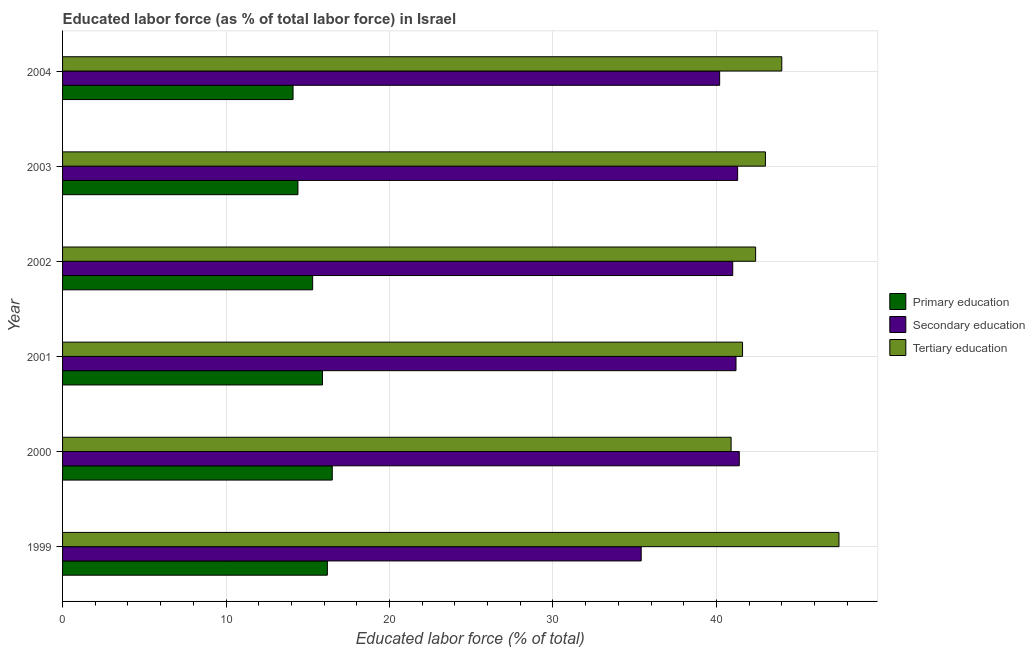How many different coloured bars are there?
Offer a very short reply. 3. How many groups of bars are there?
Make the answer very short. 6. Are the number of bars on each tick of the Y-axis equal?
Your answer should be very brief. Yes. What is the label of the 6th group of bars from the top?
Keep it short and to the point. 1999. What is the percentage of labor force who received secondary education in 2004?
Ensure brevity in your answer.  40.2. Across all years, what is the minimum percentage of labor force who received primary education?
Give a very brief answer. 14.1. In which year was the percentage of labor force who received primary education maximum?
Keep it short and to the point. 2000. In which year was the percentage of labor force who received primary education minimum?
Ensure brevity in your answer.  2004. What is the total percentage of labor force who received primary education in the graph?
Your response must be concise. 92.4. What is the difference between the percentage of labor force who received secondary education in 2001 and the percentage of labor force who received primary education in 2000?
Offer a terse response. 24.7. What is the average percentage of labor force who received secondary education per year?
Your answer should be very brief. 40.08. In the year 2000, what is the difference between the percentage of labor force who received tertiary education and percentage of labor force who received primary education?
Offer a terse response. 24.4. What is the ratio of the percentage of labor force who received secondary education in 1999 to that in 2002?
Give a very brief answer. 0.86. Is the sum of the percentage of labor force who received secondary education in 2000 and 2004 greater than the maximum percentage of labor force who received primary education across all years?
Your answer should be very brief. Yes. What does the 1st bar from the top in 2000 represents?
Your response must be concise. Tertiary education. What does the 3rd bar from the bottom in 2001 represents?
Make the answer very short. Tertiary education. Is it the case that in every year, the sum of the percentage of labor force who received primary education and percentage of labor force who received secondary education is greater than the percentage of labor force who received tertiary education?
Your answer should be very brief. Yes. What is the difference between two consecutive major ticks on the X-axis?
Ensure brevity in your answer.  10. Does the graph contain any zero values?
Your response must be concise. No. How many legend labels are there?
Your answer should be compact. 3. What is the title of the graph?
Provide a short and direct response. Educated labor force (as % of total labor force) in Israel. Does "Consumption Tax" appear as one of the legend labels in the graph?
Ensure brevity in your answer.  No. What is the label or title of the X-axis?
Offer a very short reply. Educated labor force (% of total). What is the label or title of the Y-axis?
Keep it short and to the point. Year. What is the Educated labor force (% of total) of Primary education in 1999?
Offer a terse response. 16.2. What is the Educated labor force (% of total) of Secondary education in 1999?
Your answer should be very brief. 35.4. What is the Educated labor force (% of total) in Tertiary education in 1999?
Give a very brief answer. 47.5. What is the Educated labor force (% of total) of Primary education in 2000?
Make the answer very short. 16.5. What is the Educated labor force (% of total) of Secondary education in 2000?
Offer a very short reply. 41.4. What is the Educated labor force (% of total) in Tertiary education in 2000?
Provide a succinct answer. 40.9. What is the Educated labor force (% of total) of Primary education in 2001?
Your answer should be very brief. 15.9. What is the Educated labor force (% of total) in Secondary education in 2001?
Provide a short and direct response. 41.2. What is the Educated labor force (% of total) of Tertiary education in 2001?
Your answer should be compact. 41.6. What is the Educated labor force (% of total) in Primary education in 2002?
Provide a short and direct response. 15.3. What is the Educated labor force (% of total) of Secondary education in 2002?
Offer a terse response. 41. What is the Educated labor force (% of total) in Tertiary education in 2002?
Your answer should be very brief. 42.4. What is the Educated labor force (% of total) in Primary education in 2003?
Ensure brevity in your answer.  14.4. What is the Educated labor force (% of total) in Secondary education in 2003?
Your answer should be compact. 41.3. What is the Educated labor force (% of total) of Primary education in 2004?
Keep it short and to the point. 14.1. What is the Educated labor force (% of total) of Secondary education in 2004?
Provide a short and direct response. 40.2. Across all years, what is the maximum Educated labor force (% of total) of Secondary education?
Your response must be concise. 41.4. Across all years, what is the maximum Educated labor force (% of total) in Tertiary education?
Make the answer very short. 47.5. Across all years, what is the minimum Educated labor force (% of total) of Primary education?
Provide a succinct answer. 14.1. Across all years, what is the minimum Educated labor force (% of total) in Secondary education?
Your answer should be very brief. 35.4. Across all years, what is the minimum Educated labor force (% of total) of Tertiary education?
Offer a terse response. 40.9. What is the total Educated labor force (% of total) of Primary education in the graph?
Provide a short and direct response. 92.4. What is the total Educated labor force (% of total) in Secondary education in the graph?
Provide a short and direct response. 240.5. What is the total Educated labor force (% of total) in Tertiary education in the graph?
Provide a short and direct response. 259.4. What is the difference between the Educated labor force (% of total) of Primary education in 1999 and that in 2001?
Make the answer very short. 0.3. What is the difference between the Educated labor force (% of total) of Secondary education in 1999 and that in 2001?
Your response must be concise. -5.8. What is the difference between the Educated labor force (% of total) in Tertiary education in 1999 and that in 2001?
Provide a short and direct response. 5.9. What is the difference between the Educated labor force (% of total) in Primary education in 1999 and that in 2002?
Make the answer very short. 0.9. What is the difference between the Educated labor force (% of total) of Tertiary education in 1999 and that in 2003?
Offer a terse response. 4.5. What is the difference between the Educated labor force (% of total) in Tertiary education in 2000 and that in 2001?
Offer a very short reply. -0.7. What is the difference between the Educated labor force (% of total) in Primary education in 2000 and that in 2002?
Keep it short and to the point. 1.2. What is the difference between the Educated labor force (% of total) of Secondary education in 2000 and that in 2002?
Give a very brief answer. 0.4. What is the difference between the Educated labor force (% of total) in Secondary education in 2000 and that in 2003?
Your answer should be very brief. 0.1. What is the difference between the Educated labor force (% of total) of Tertiary education in 2000 and that in 2003?
Provide a succinct answer. -2.1. What is the difference between the Educated labor force (% of total) in Secondary education in 2000 and that in 2004?
Make the answer very short. 1.2. What is the difference between the Educated labor force (% of total) in Primary education in 2001 and that in 2003?
Provide a short and direct response. 1.5. What is the difference between the Educated labor force (% of total) of Tertiary education in 2002 and that in 2003?
Provide a succinct answer. -0.6. What is the difference between the Educated labor force (% of total) of Primary education in 2002 and that in 2004?
Provide a short and direct response. 1.2. What is the difference between the Educated labor force (% of total) in Tertiary education in 2002 and that in 2004?
Ensure brevity in your answer.  -1.6. What is the difference between the Educated labor force (% of total) in Primary education in 2003 and that in 2004?
Provide a short and direct response. 0.3. What is the difference between the Educated labor force (% of total) in Secondary education in 2003 and that in 2004?
Make the answer very short. 1.1. What is the difference between the Educated labor force (% of total) of Primary education in 1999 and the Educated labor force (% of total) of Secondary education in 2000?
Your answer should be very brief. -25.2. What is the difference between the Educated labor force (% of total) of Primary education in 1999 and the Educated labor force (% of total) of Tertiary education in 2000?
Offer a terse response. -24.7. What is the difference between the Educated labor force (% of total) in Secondary education in 1999 and the Educated labor force (% of total) in Tertiary education in 2000?
Keep it short and to the point. -5.5. What is the difference between the Educated labor force (% of total) of Primary education in 1999 and the Educated labor force (% of total) of Secondary education in 2001?
Ensure brevity in your answer.  -25. What is the difference between the Educated labor force (% of total) in Primary education in 1999 and the Educated labor force (% of total) in Tertiary education in 2001?
Make the answer very short. -25.4. What is the difference between the Educated labor force (% of total) of Secondary education in 1999 and the Educated labor force (% of total) of Tertiary education in 2001?
Offer a very short reply. -6.2. What is the difference between the Educated labor force (% of total) of Primary education in 1999 and the Educated labor force (% of total) of Secondary education in 2002?
Offer a terse response. -24.8. What is the difference between the Educated labor force (% of total) of Primary education in 1999 and the Educated labor force (% of total) of Tertiary education in 2002?
Offer a terse response. -26.2. What is the difference between the Educated labor force (% of total) of Secondary education in 1999 and the Educated labor force (% of total) of Tertiary education in 2002?
Your response must be concise. -7. What is the difference between the Educated labor force (% of total) in Primary education in 1999 and the Educated labor force (% of total) in Secondary education in 2003?
Give a very brief answer. -25.1. What is the difference between the Educated labor force (% of total) in Primary education in 1999 and the Educated labor force (% of total) in Tertiary education in 2003?
Provide a short and direct response. -26.8. What is the difference between the Educated labor force (% of total) of Secondary education in 1999 and the Educated labor force (% of total) of Tertiary education in 2003?
Keep it short and to the point. -7.6. What is the difference between the Educated labor force (% of total) in Primary education in 1999 and the Educated labor force (% of total) in Tertiary education in 2004?
Offer a very short reply. -27.8. What is the difference between the Educated labor force (% of total) in Primary education in 2000 and the Educated labor force (% of total) in Secondary education in 2001?
Provide a short and direct response. -24.7. What is the difference between the Educated labor force (% of total) in Primary education in 2000 and the Educated labor force (% of total) in Tertiary education in 2001?
Your answer should be very brief. -25.1. What is the difference between the Educated labor force (% of total) in Secondary education in 2000 and the Educated labor force (% of total) in Tertiary education in 2001?
Your response must be concise. -0.2. What is the difference between the Educated labor force (% of total) in Primary education in 2000 and the Educated labor force (% of total) in Secondary education in 2002?
Provide a succinct answer. -24.5. What is the difference between the Educated labor force (% of total) of Primary education in 2000 and the Educated labor force (% of total) of Tertiary education in 2002?
Ensure brevity in your answer.  -25.9. What is the difference between the Educated labor force (% of total) in Primary education in 2000 and the Educated labor force (% of total) in Secondary education in 2003?
Offer a very short reply. -24.8. What is the difference between the Educated labor force (% of total) of Primary education in 2000 and the Educated labor force (% of total) of Tertiary education in 2003?
Your response must be concise. -26.5. What is the difference between the Educated labor force (% of total) of Secondary education in 2000 and the Educated labor force (% of total) of Tertiary education in 2003?
Your response must be concise. -1.6. What is the difference between the Educated labor force (% of total) in Primary education in 2000 and the Educated labor force (% of total) in Secondary education in 2004?
Make the answer very short. -23.7. What is the difference between the Educated labor force (% of total) in Primary education in 2000 and the Educated labor force (% of total) in Tertiary education in 2004?
Provide a succinct answer. -27.5. What is the difference between the Educated labor force (% of total) in Primary education in 2001 and the Educated labor force (% of total) in Secondary education in 2002?
Offer a terse response. -25.1. What is the difference between the Educated labor force (% of total) of Primary education in 2001 and the Educated labor force (% of total) of Tertiary education in 2002?
Your response must be concise. -26.5. What is the difference between the Educated labor force (% of total) of Primary education in 2001 and the Educated labor force (% of total) of Secondary education in 2003?
Your answer should be very brief. -25.4. What is the difference between the Educated labor force (% of total) in Primary education in 2001 and the Educated labor force (% of total) in Tertiary education in 2003?
Ensure brevity in your answer.  -27.1. What is the difference between the Educated labor force (% of total) of Primary education in 2001 and the Educated labor force (% of total) of Secondary education in 2004?
Offer a terse response. -24.3. What is the difference between the Educated labor force (% of total) of Primary education in 2001 and the Educated labor force (% of total) of Tertiary education in 2004?
Offer a terse response. -28.1. What is the difference between the Educated labor force (% of total) of Primary education in 2002 and the Educated labor force (% of total) of Tertiary education in 2003?
Offer a very short reply. -27.7. What is the difference between the Educated labor force (% of total) of Primary education in 2002 and the Educated labor force (% of total) of Secondary education in 2004?
Provide a succinct answer. -24.9. What is the difference between the Educated labor force (% of total) in Primary education in 2002 and the Educated labor force (% of total) in Tertiary education in 2004?
Your response must be concise. -28.7. What is the difference between the Educated labor force (% of total) in Primary education in 2003 and the Educated labor force (% of total) in Secondary education in 2004?
Your response must be concise. -25.8. What is the difference between the Educated labor force (% of total) of Primary education in 2003 and the Educated labor force (% of total) of Tertiary education in 2004?
Provide a short and direct response. -29.6. What is the difference between the Educated labor force (% of total) in Secondary education in 2003 and the Educated labor force (% of total) in Tertiary education in 2004?
Ensure brevity in your answer.  -2.7. What is the average Educated labor force (% of total) in Primary education per year?
Your response must be concise. 15.4. What is the average Educated labor force (% of total) of Secondary education per year?
Your response must be concise. 40.08. What is the average Educated labor force (% of total) in Tertiary education per year?
Ensure brevity in your answer.  43.23. In the year 1999, what is the difference between the Educated labor force (% of total) of Primary education and Educated labor force (% of total) of Secondary education?
Offer a very short reply. -19.2. In the year 1999, what is the difference between the Educated labor force (% of total) of Primary education and Educated labor force (% of total) of Tertiary education?
Provide a short and direct response. -31.3. In the year 2000, what is the difference between the Educated labor force (% of total) of Primary education and Educated labor force (% of total) of Secondary education?
Your answer should be very brief. -24.9. In the year 2000, what is the difference between the Educated labor force (% of total) of Primary education and Educated labor force (% of total) of Tertiary education?
Your answer should be compact. -24.4. In the year 2001, what is the difference between the Educated labor force (% of total) of Primary education and Educated labor force (% of total) of Secondary education?
Your answer should be very brief. -25.3. In the year 2001, what is the difference between the Educated labor force (% of total) of Primary education and Educated labor force (% of total) of Tertiary education?
Provide a succinct answer. -25.7. In the year 2002, what is the difference between the Educated labor force (% of total) of Primary education and Educated labor force (% of total) of Secondary education?
Ensure brevity in your answer.  -25.7. In the year 2002, what is the difference between the Educated labor force (% of total) in Primary education and Educated labor force (% of total) in Tertiary education?
Your response must be concise. -27.1. In the year 2002, what is the difference between the Educated labor force (% of total) in Secondary education and Educated labor force (% of total) in Tertiary education?
Give a very brief answer. -1.4. In the year 2003, what is the difference between the Educated labor force (% of total) of Primary education and Educated labor force (% of total) of Secondary education?
Give a very brief answer. -26.9. In the year 2003, what is the difference between the Educated labor force (% of total) of Primary education and Educated labor force (% of total) of Tertiary education?
Ensure brevity in your answer.  -28.6. In the year 2004, what is the difference between the Educated labor force (% of total) in Primary education and Educated labor force (% of total) in Secondary education?
Make the answer very short. -26.1. In the year 2004, what is the difference between the Educated labor force (% of total) in Primary education and Educated labor force (% of total) in Tertiary education?
Provide a short and direct response. -29.9. In the year 2004, what is the difference between the Educated labor force (% of total) in Secondary education and Educated labor force (% of total) in Tertiary education?
Your answer should be compact. -3.8. What is the ratio of the Educated labor force (% of total) of Primary education in 1999 to that in 2000?
Offer a very short reply. 0.98. What is the ratio of the Educated labor force (% of total) in Secondary education in 1999 to that in 2000?
Make the answer very short. 0.86. What is the ratio of the Educated labor force (% of total) in Tertiary education in 1999 to that in 2000?
Provide a succinct answer. 1.16. What is the ratio of the Educated labor force (% of total) of Primary education in 1999 to that in 2001?
Provide a succinct answer. 1.02. What is the ratio of the Educated labor force (% of total) of Secondary education in 1999 to that in 2001?
Provide a short and direct response. 0.86. What is the ratio of the Educated labor force (% of total) of Tertiary education in 1999 to that in 2001?
Provide a succinct answer. 1.14. What is the ratio of the Educated labor force (% of total) of Primary education in 1999 to that in 2002?
Your answer should be compact. 1.06. What is the ratio of the Educated labor force (% of total) of Secondary education in 1999 to that in 2002?
Offer a terse response. 0.86. What is the ratio of the Educated labor force (% of total) of Tertiary education in 1999 to that in 2002?
Provide a succinct answer. 1.12. What is the ratio of the Educated labor force (% of total) of Primary education in 1999 to that in 2003?
Give a very brief answer. 1.12. What is the ratio of the Educated labor force (% of total) in Tertiary education in 1999 to that in 2003?
Your answer should be very brief. 1.1. What is the ratio of the Educated labor force (% of total) of Primary education in 1999 to that in 2004?
Keep it short and to the point. 1.15. What is the ratio of the Educated labor force (% of total) of Secondary education in 1999 to that in 2004?
Your response must be concise. 0.88. What is the ratio of the Educated labor force (% of total) in Tertiary education in 1999 to that in 2004?
Ensure brevity in your answer.  1.08. What is the ratio of the Educated labor force (% of total) of Primary education in 2000 to that in 2001?
Your answer should be very brief. 1.04. What is the ratio of the Educated labor force (% of total) of Secondary education in 2000 to that in 2001?
Keep it short and to the point. 1. What is the ratio of the Educated labor force (% of total) of Tertiary education in 2000 to that in 2001?
Ensure brevity in your answer.  0.98. What is the ratio of the Educated labor force (% of total) in Primary education in 2000 to that in 2002?
Offer a terse response. 1.08. What is the ratio of the Educated labor force (% of total) in Secondary education in 2000 to that in 2002?
Your answer should be very brief. 1.01. What is the ratio of the Educated labor force (% of total) of Tertiary education in 2000 to that in 2002?
Offer a terse response. 0.96. What is the ratio of the Educated labor force (% of total) in Primary education in 2000 to that in 2003?
Your response must be concise. 1.15. What is the ratio of the Educated labor force (% of total) in Tertiary education in 2000 to that in 2003?
Ensure brevity in your answer.  0.95. What is the ratio of the Educated labor force (% of total) in Primary education in 2000 to that in 2004?
Give a very brief answer. 1.17. What is the ratio of the Educated labor force (% of total) of Secondary education in 2000 to that in 2004?
Provide a short and direct response. 1.03. What is the ratio of the Educated labor force (% of total) in Tertiary education in 2000 to that in 2004?
Offer a very short reply. 0.93. What is the ratio of the Educated labor force (% of total) of Primary education in 2001 to that in 2002?
Your answer should be very brief. 1.04. What is the ratio of the Educated labor force (% of total) in Secondary education in 2001 to that in 2002?
Give a very brief answer. 1. What is the ratio of the Educated labor force (% of total) of Tertiary education in 2001 to that in 2002?
Keep it short and to the point. 0.98. What is the ratio of the Educated labor force (% of total) of Primary education in 2001 to that in 2003?
Keep it short and to the point. 1.1. What is the ratio of the Educated labor force (% of total) in Tertiary education in 2001 to that in 2003?
Ensure brevity in your answer.  0.97. What is the ratio of the Educated labor force (% of total) of Primary education in 2001 to that in 2004?
Provide a succinct answer. 1.13. What is the ratio of the Educated labor force (% of total) in Secondary education in 2001 to that in 2004?
Your response must be concise. 1.02. What is the ratio of the Educated labor force (% of total) of Tertiary education in 2001 to that in 2004?
Offer a very short reply. 0.95. What is the ratio of the Educated labor force (% of total) of Tertiary education in 2002 to that in 2003?
Give a very brief answer. 0.99. What is the ratio of the Educated labor force (% of total) in Primary education in 2002 to that in 2004?
Give a very brief answer. 1.09. What is the ratio of the Educated labor force (% of total) in Secondary education in 2002 to that in 2004?
Keep it short and to the point. 1.02. What is the ratio of the Educated labor force (% of total) in Tertiary education in 2002 to that in 2004?
Your response must be concise. 0.96. What is the ratio of the Educated labor force (% of total) in Primary education in 2003 to that in 2004?
Provide a short and direct response. 1.02. What is the ratio of the Educated labor force (% of total) of Secondary education in 2003 to that in 2004?
Your answer should be very brief. 1.03. What is the ratio of the Educated labor force (% of total) of Tertiary education in 2003 to that in 2004?
Offer a very short reply. 0.98. What is the difference between the highest and the second highest Educated labor force (% of total) in Primary education?
Your response must be concise. 0.3. What is the difference between the highest and the second highest Educated labor force (% of total) of Tertiary education?
Your response must be concise. 3.5. What is the difference between the highest and the lowest Educated labor force (% of total) in Primary education?
Your response must be concise. 2.4. What is the difference between the highest and the lowest Educated labor force (% of total) of Secondary education?
Offer a very short reply. 6. 